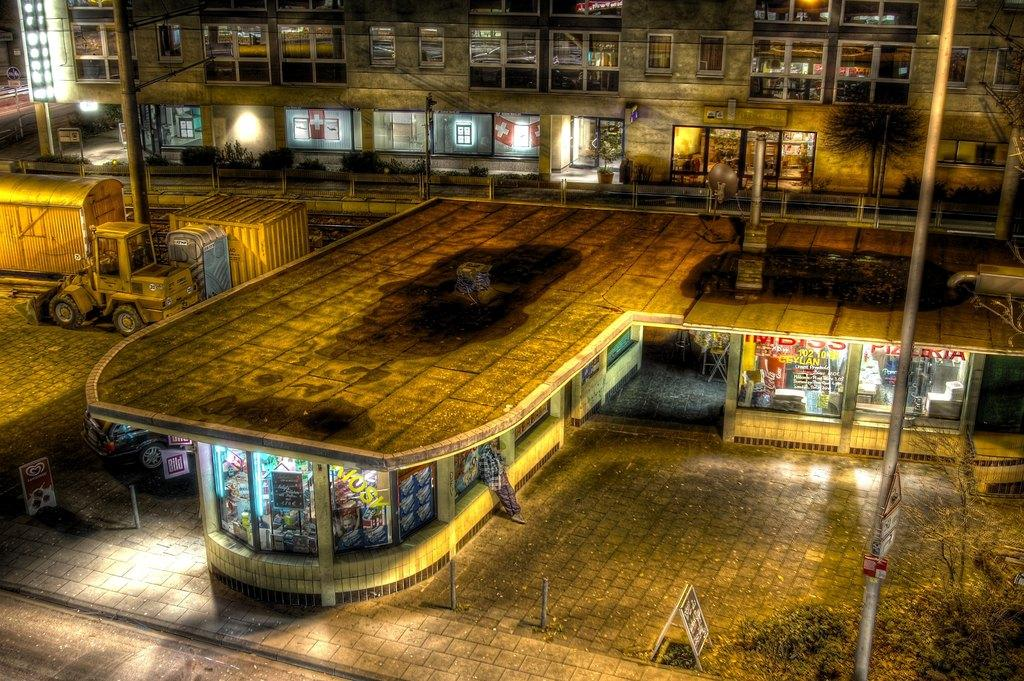What type of structures can be seen in the image? There are buildings in the image. What else is present in the image besides buildings? There are vehicles, boards, poles, objects on the ground, grass, plants, and containers in the image. Can you describe the ground in the image? The ground is visible in the image, and there are objects on it. What type of vegetation is present in the image? There is grass and plants in the image. What else can be found on the ground in the image? Containers are also present on the ground. Can you describe the battle taking place in the image? There is no battle present in the image; it features buildings, vehicles, boards, poles, objects on the ground, grass, plants, and containers. What type of sea creatures can be seen swimming in the image? There is no sea or sea creatures present in the image. 